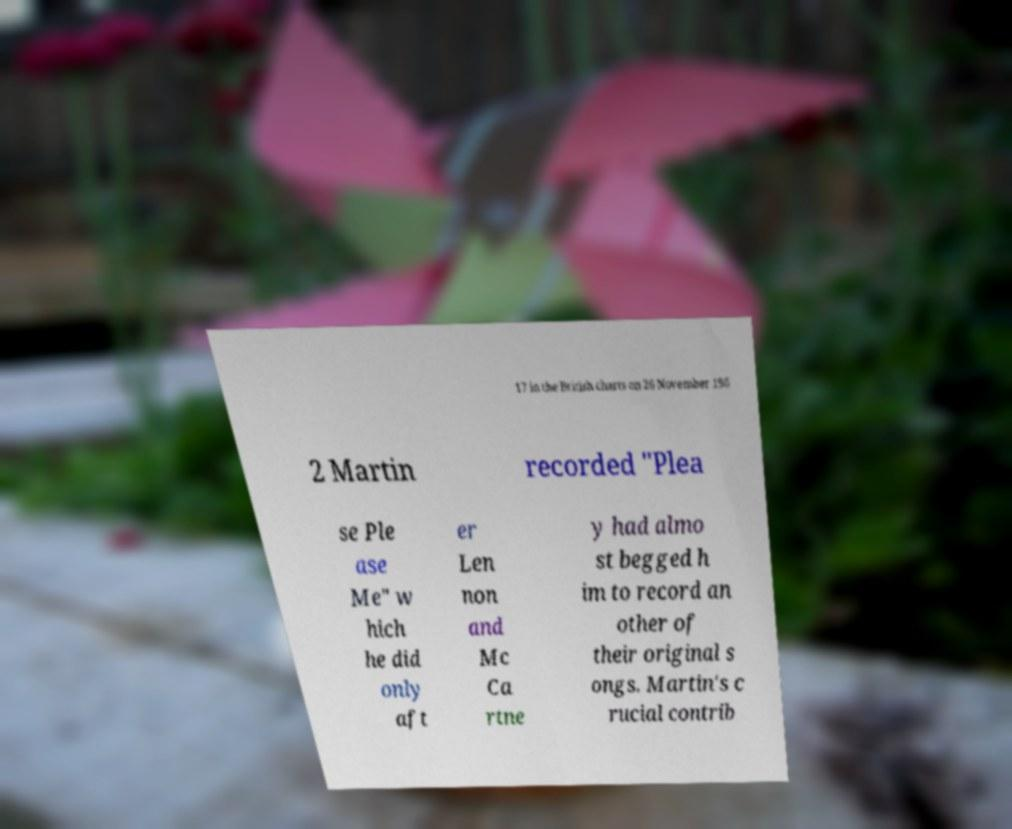Could you extract and type out the text from this image? 17 in the British charts on 26 November 196 2 Martin recorded "Plea se Ple ase Me" w hich he did only aft er Len non and Mc Ca rtne y had almo st begged h im to record an other of their original s ongs. Martin's c rucial contrib 